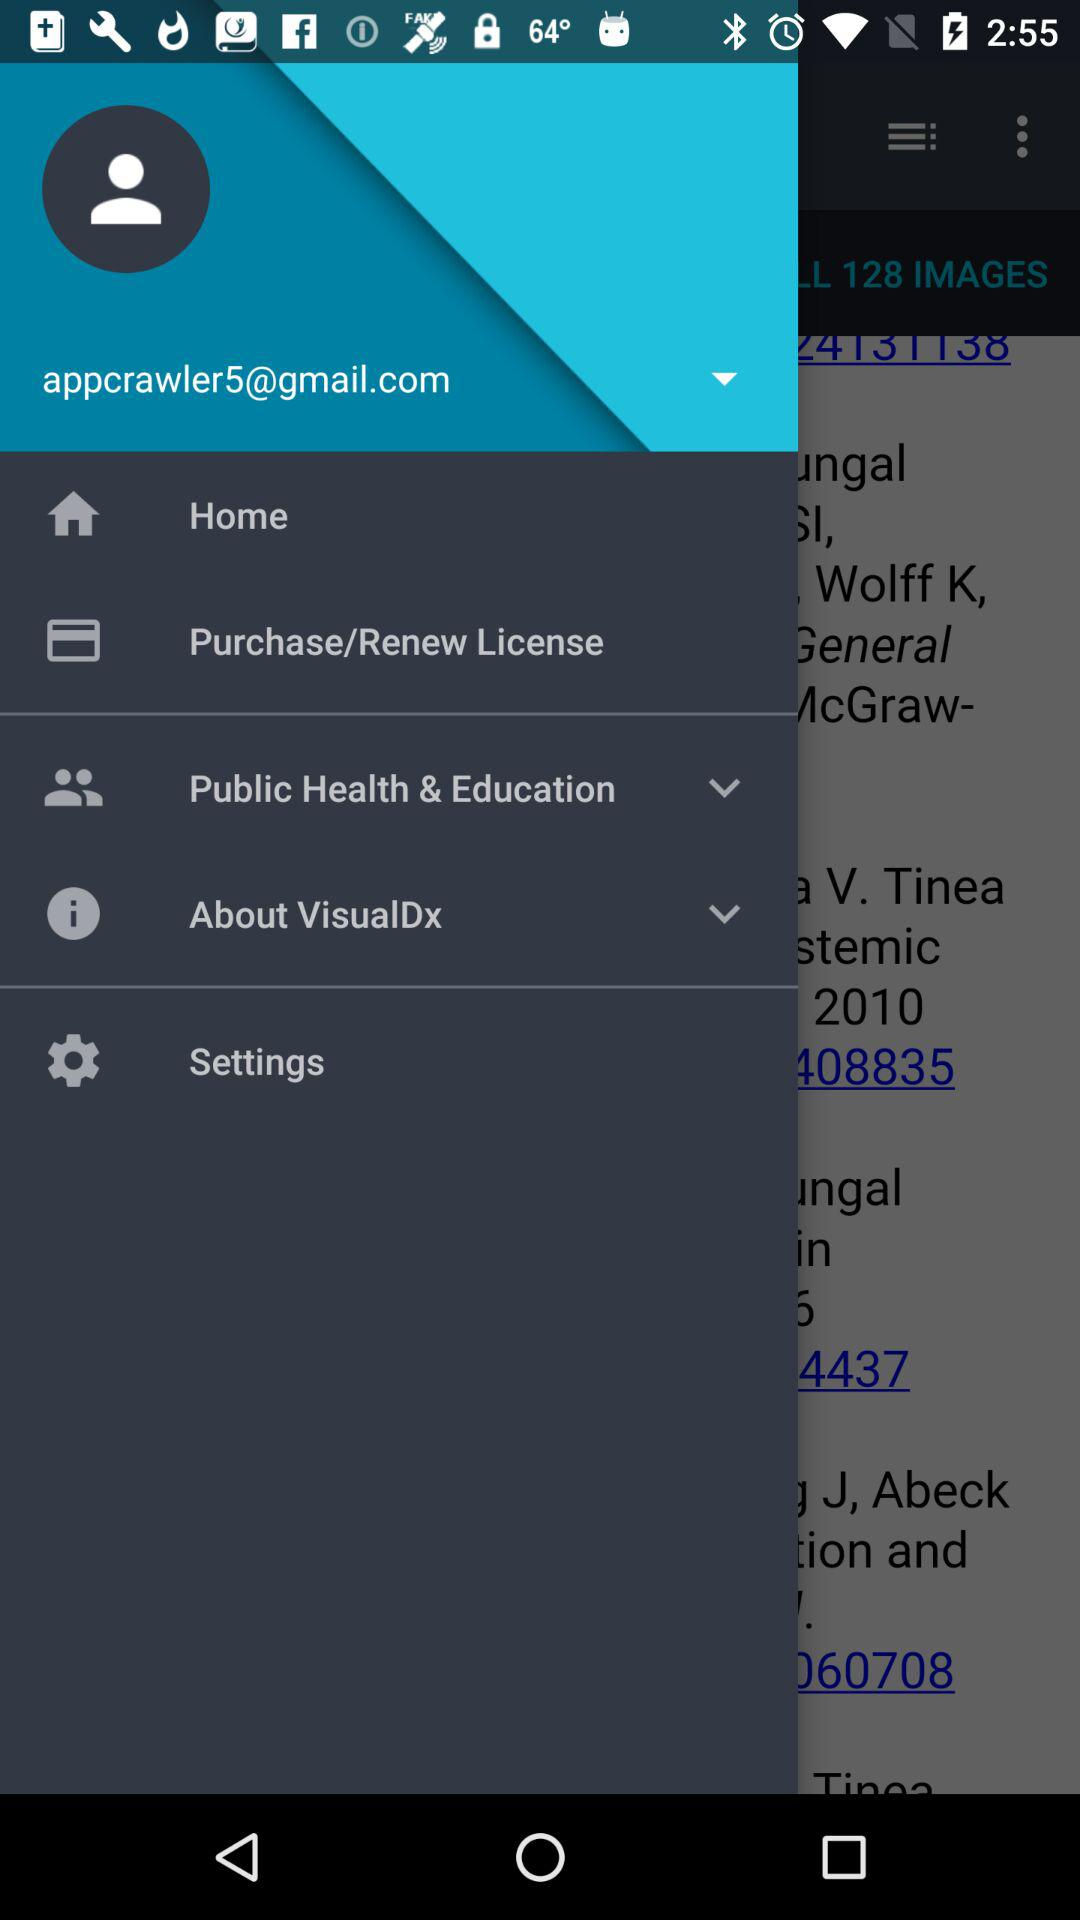How many notifications are there in "Settings"?
When the provided information is insufficient, respond with <no answer>. <no answer> 